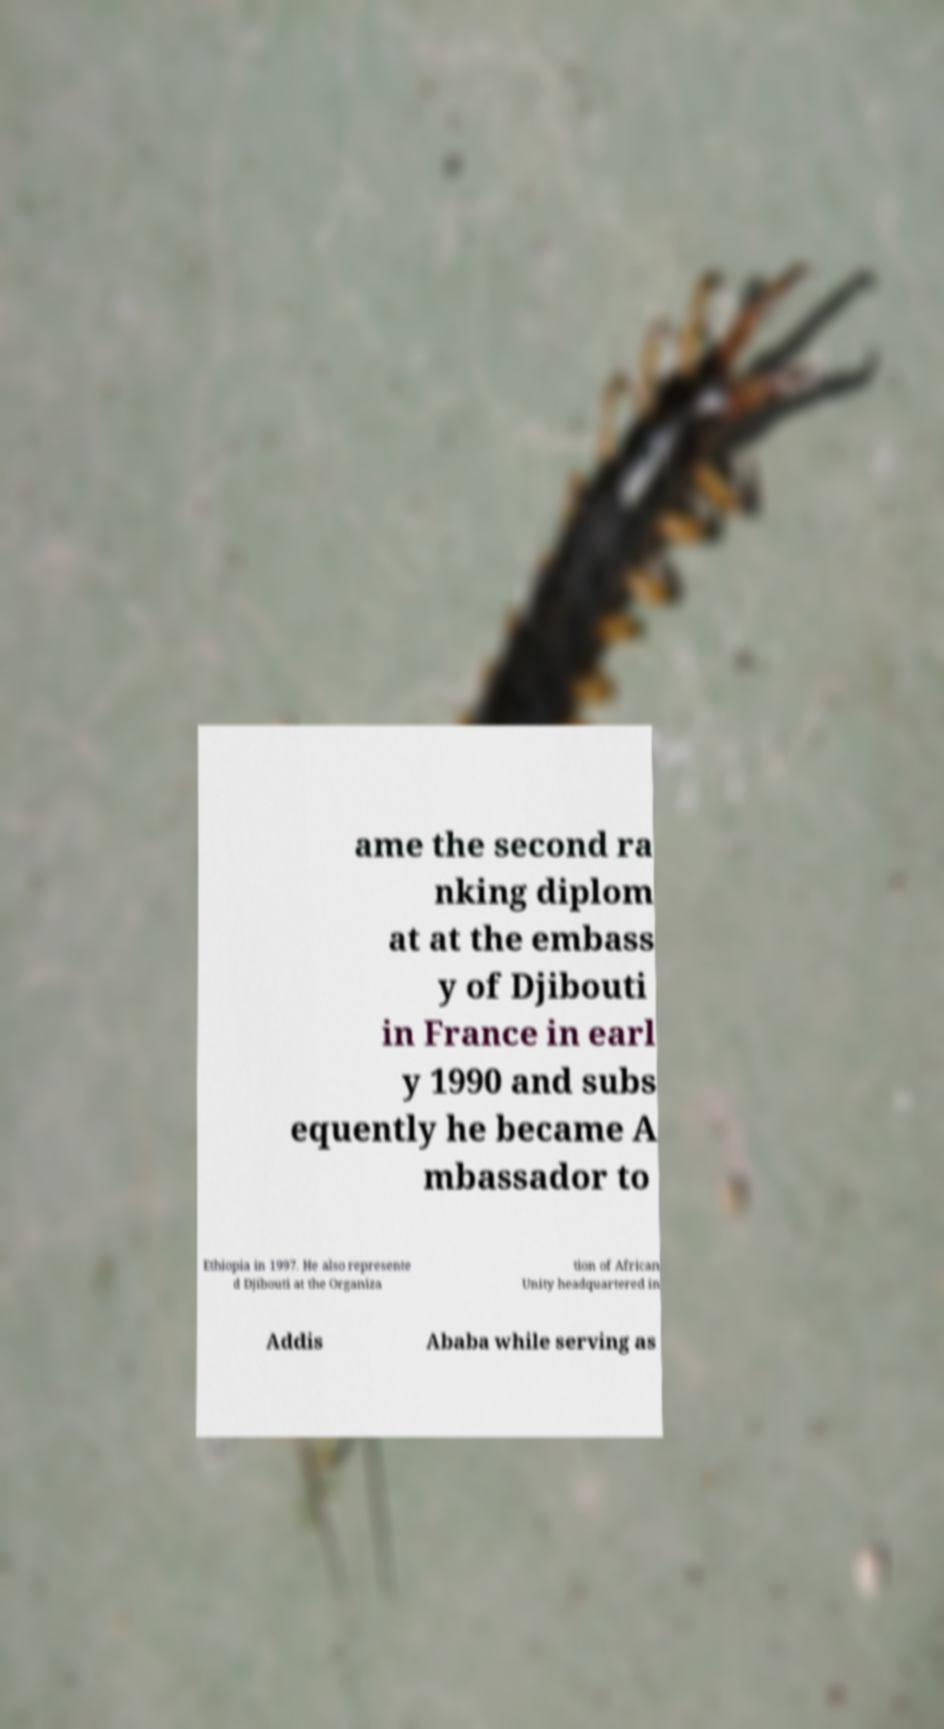I need the written content from this picture converted into text. Can you do that? ame the second ra nking diplom at at the embass y of Djibouti in France in earl y 1990 and subs equently he became A mbassador to Ethiopia in 1997. He also represente d Djibouti at the Organiza tion of African Unity headquartered in Addis Ababa while serving as 